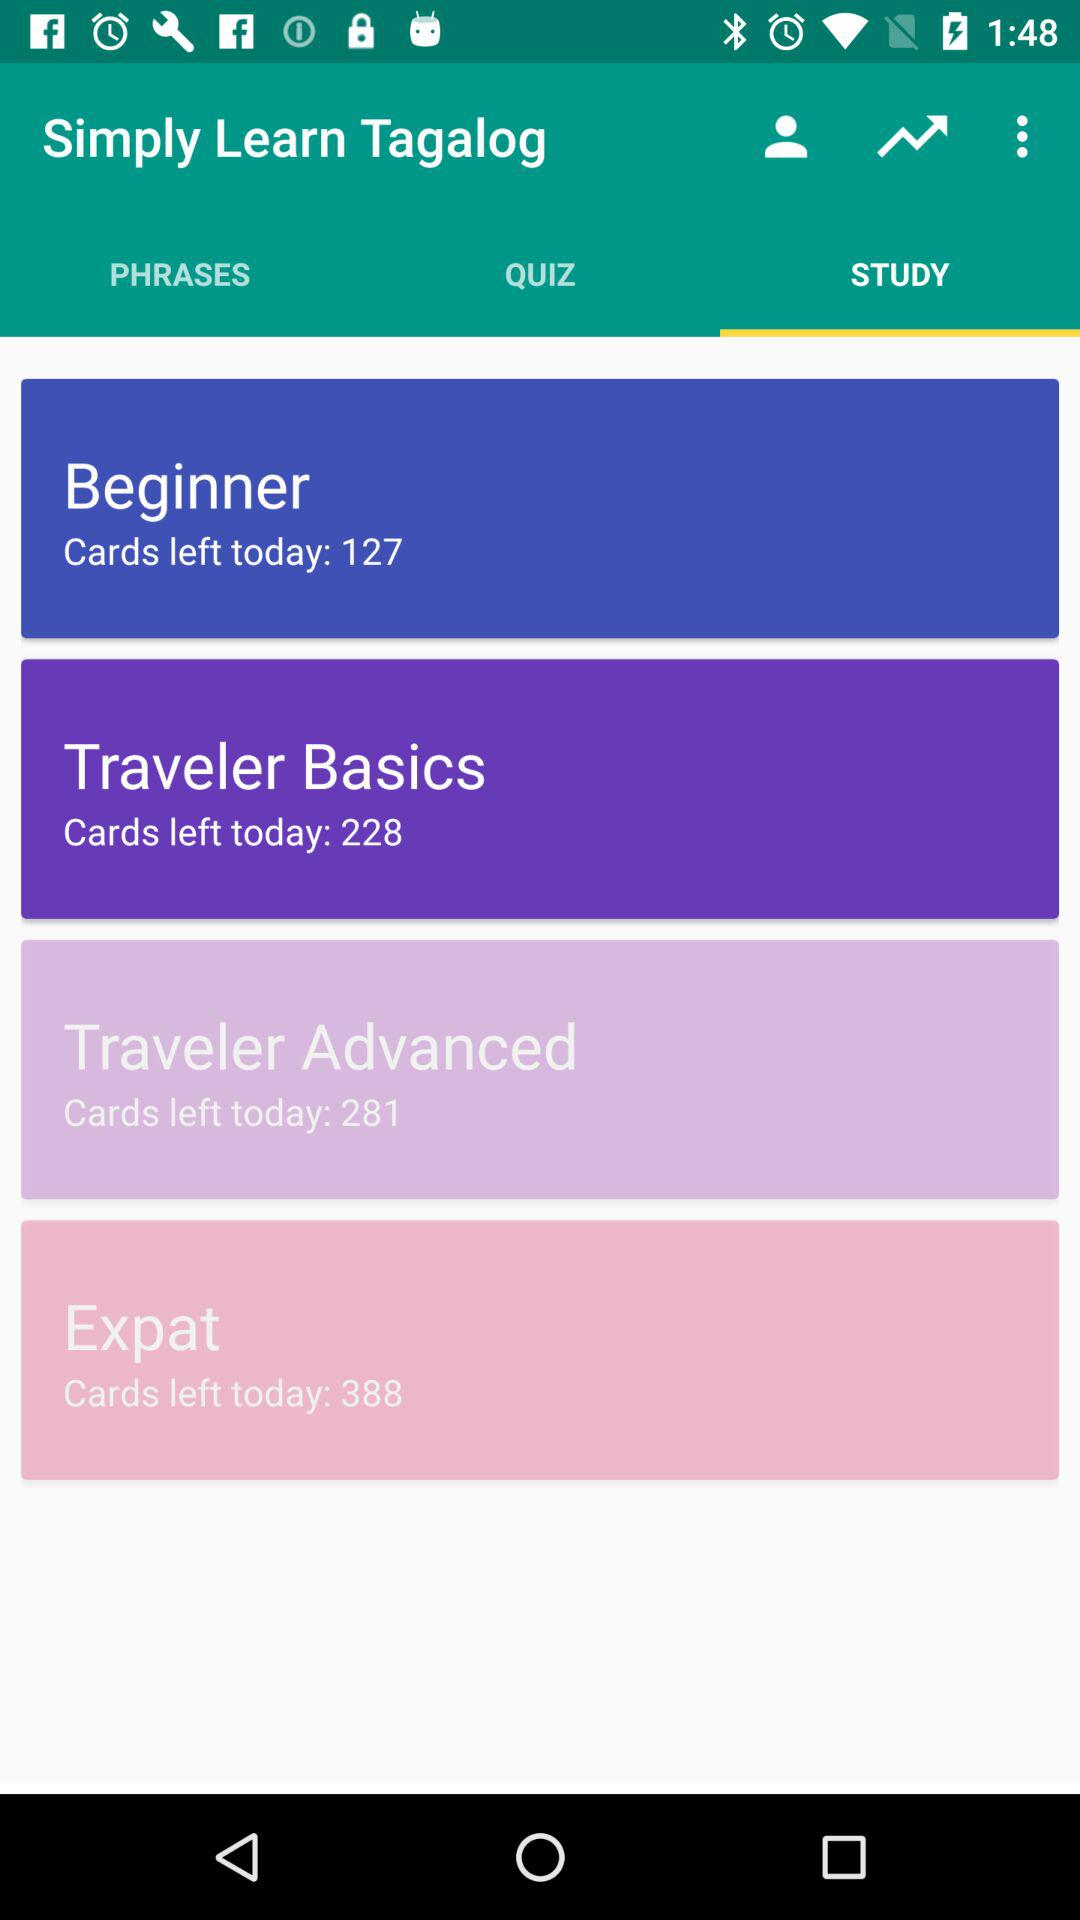How many more cards are there in the Traveler Advanced course than the Traveler Basics course?
Answer the question using a single word or phrase. 53 